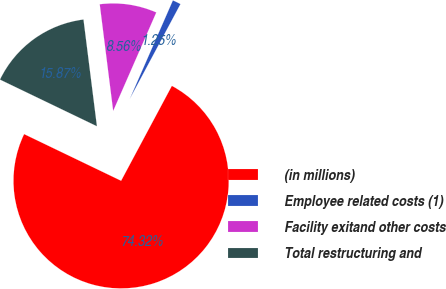Convert chart to OTSL. <chart><loc_0><loc_0><loc_500><loc_500><pie_chart><fcel>(in millions)<fcel>Employee related costs (1)<fcel>Facility exitand other costs<fcel>Total restructuring and<nl><fcel>74.33%<fcel>1.25%<fcel>8.56%<fcel>15.87%<nl></chart> 